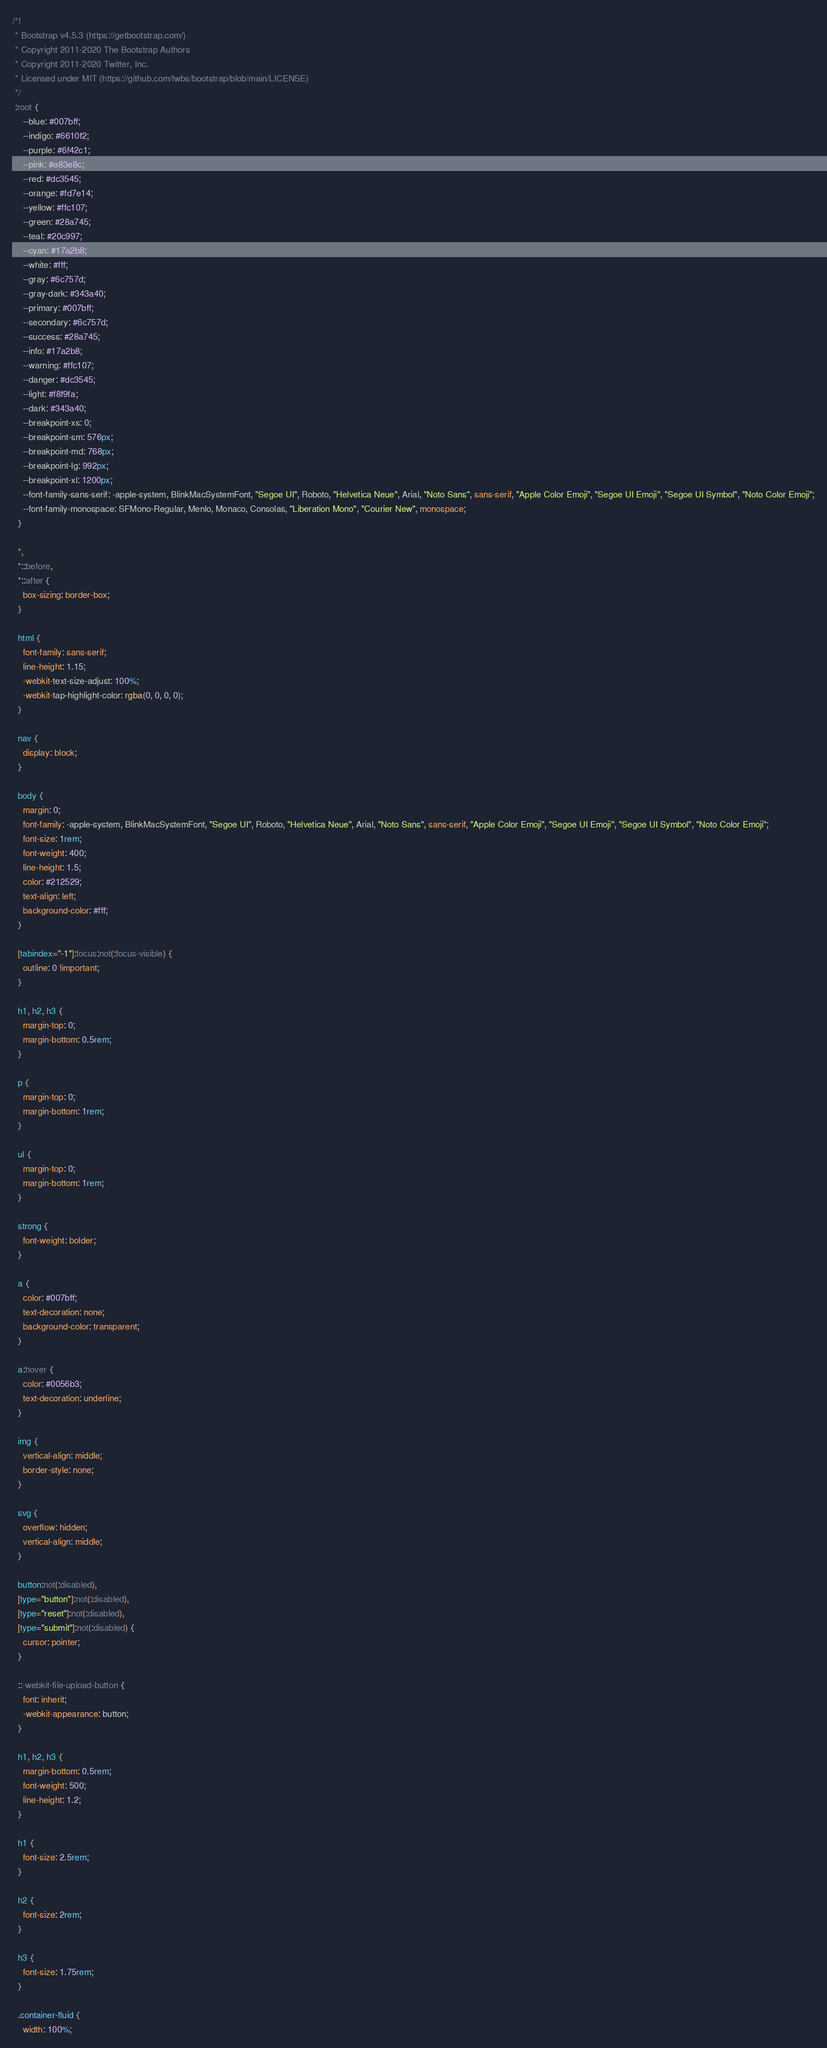<code> <loc_0><loc_0><loc_500><loc_500><_CSS_>/*!
 * Bootstrap v4.5.3 (https://getbootstrap.com/)
 * Copyright 2011-2020 The Bootstrap Authors
 * Copyright 2011-2020 Twitter, Inc.
 * Licensed under MIT (https://github.com/twbs/bootstrap/blob/main/LICENSE)
 */
 :root {
    --blue: #007bff;
    --indigo: #6610f2;
    --purple: #6f42c1;
    --pink: #e83e8c;
    --red: #dc3545;
    --orange: #fd7e14;
    --yellow: #ffc107;
    --green: #28a745;
    --teal: #20c997;
    --cyan: #17a2b8;
    --white: #fff;
    --gray: #6c757d;
    --gray-dark: #343a40;
    --primary: #007bff;
    --secondary: #6c757d;
    --success: #28a745;
    --info: #17a2b8;
    --warning: #ffc107;
    --danger: #dc3545;
    --light: #f8f9fa;
    --dark: #343a40;
    --breakpoint-xs: 0;
    --breakpoint-sm: 576px;
    --breakpoint-md: 768px;
    --breakpoint-lg: 992px;
    --breakpoint-xl: 1200px;
    --font-family-sans-serif: -apple-system, BlinkMacSystemFont, "Segoe UI", Roboto, "Helvetica Neue", Arial, "Noto Sans", sans-serif, "Apple Color Emoji", "Segoe UI Emoji", "Segoe UI Symbol", "Noto Color Emoji";
    --font-family-monospace: SFMono-Regular, Menlo, Monaco, Consolas, "Liberation Mono", "Courier New", monospace;
  }
  
  *,
  *::before,
  *::after {
    box-sizing: border-box;
  }
  
  html {
    font-family: sans-serif;
    line-height: 1.15;
    -webkit-text-size-adjust: 100%;
    -webkit-tap-highlight-color: rgba(0, 0, 0, 0);
  }
  
  nav {
    display: block;
  }
  
  body {
    margin: 0;
    font-family: -apple-system, BlinkMacSystemFont, "Segoe UI", Roboto, "Helvetica Neue", Arial, "Noto Sans", sans-serif, "Apple Color Emoji", "Segoe UI Emoji", "Segoe UI Symbol", "Noto Color Emoji";
    font-size: 1rem;
    font-weight: 400;
    line-height: 1.5;
    color: #212529;
    text-align: left;
    background-color: #fff;
  }
  
  [tabindex="-1"]:focus:not(:focus-visible) {
    outline: 0 !important;
  }
  
  h1, h2, h3 {
    margin-top: 0;
    margin-bottom: 0.5rem;
  }
  
  p {
    margin-top: 0;
    margin-bottom: 1rem;
  }
  
  ul {
    margin-top: 0;
    margin-bottom: 1rem;
  }
  
  strong {
    font-weight: bolder;
  }
  
  a {
    color: #007bff;
    text-decoration: none;
    background-color: transparent;
  }
  
  a:hover {
    color: #0056b3;
    text-decoration: underline;
  }
  
  img {
    vertical-align: middle;
    border-style: none;
  }
  
  svg {
    overflow: hidden;
    vertical-align: middle;
  }
  
  button:not(:disabled),
  [type="button"]:not(:disabled),
  [type="reset"]:not(:disabled),
  [type="submit"]:not(:disabled) {
    cursor: pointer;
  }
  
  ::-webkit-file-upload-button {
    font: inherit;
    -webkit-appearance: button;
  }
  
  h1, h2, h3 {
    margin-bottom: 0.5rem;
    font-weight: 500;
    line-height: 1.2;
  }
  
  h1 {
    font-size: 2.5rem;
  }
  
  h2 {
    font-size: 2rem;
  }
  
  h3 {
    font-size: 1.75rem;
  }
  
  .container-fluid {
    width: 100%;</code> 